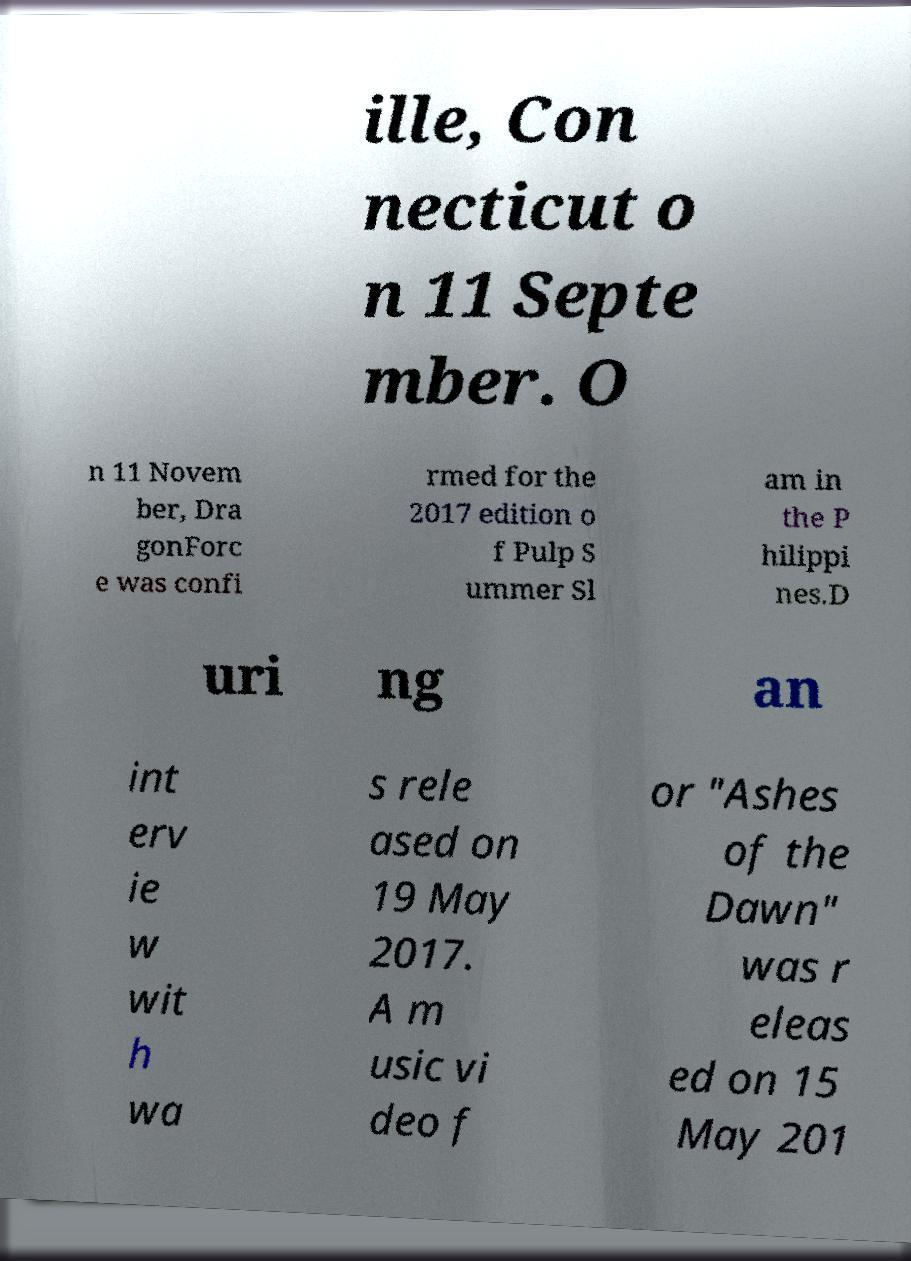I need the written content from this picture converted into text. Can you do that? ille, Con necticut o n 11 Septe mber. O n 11 Novem ber, Dra gonForc e was confi rmed for the 2017 edition o f Pulp S ummer Sl am in the P hilippi nes.D uri ng an int erv ie w wit h wa s rele ased on 19 May 2017. A m usic vi deo f or "Ashes of the Dawn" was r eleas ed on 15 May 201 